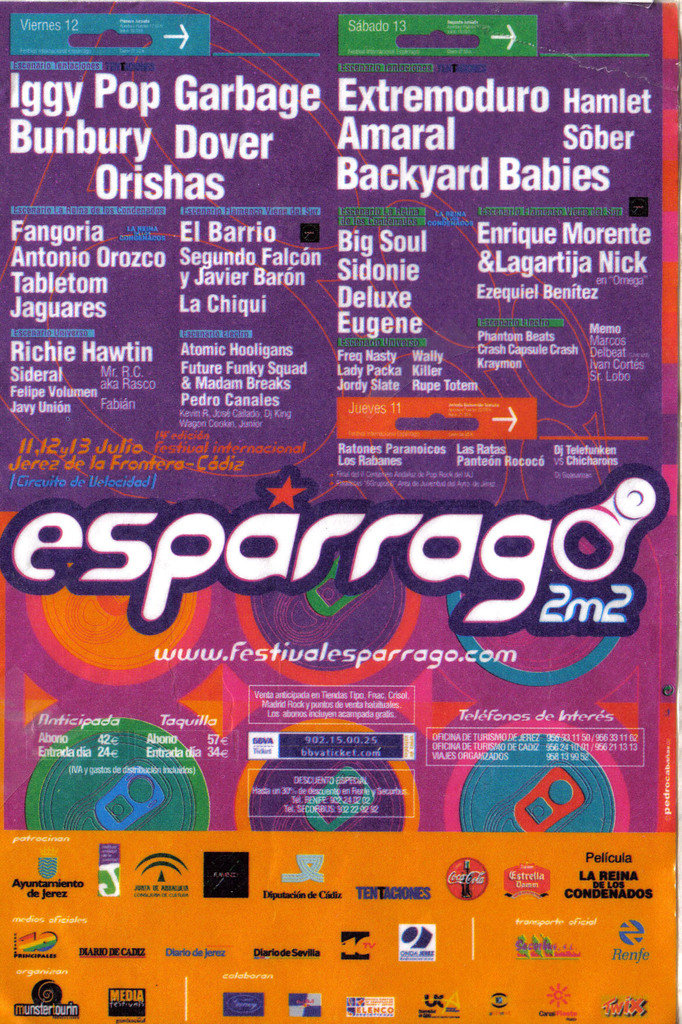Provide a one-sentence caption for the provided image. A colorful and vibrant poster advertising the 'Festival Esparrago Rock,' featuring a lineup of artists like Iggy Pop, Amaral, and Extremoduro, marked with various sponsor logos and event details for July 12 and 13 in Jerez, Spain. 